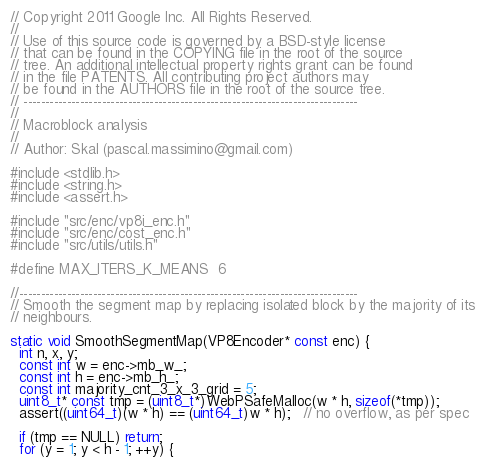Convert code to text. <code><loc_0><loc_0><loc_500><loc_500><_C_>// Copyright 2011 Google Inc. All Rights Reserved.
//
// Use of this source code is governed by a BSD-style license
// that can be found in the COPYING file in the root of the source
// tree. An additional intellectual property rights grant can be found
// in the file PATENTS. All contributing project authors may
// be found in the AUTHORS file in the root of the source tree.
// -----------------------------------------------------------------------------
//
// Macroblock analysis
//
// Author: Skal (pascal.massimino@gmail.com)

#include <stdlib.h>
#include <string.h>
#include <assert.h>

#include "src/enc/vp8i_enc.h"
#include "src/enc/cost_enc.h"
#include "src/utils/utils.h"

#define MAX_ITERS_K_MEANS  6

//------------------------------------------------------------------------------
// Smooth the segment map by replacing isolated block by the majority of its
// neighbours.

static void SmoothSegmentMap(VP8Encoder* const enc) {
  int n, x, y;
  const int w = enc->mb_w_;
  const int h = enc->mb_h_;
  const int majority_cnt_3_x_3_grid = 5;
  uint8_t* const tmp = (uint8_t*)WebPSafeMalloc(w * h, sizeof(*tmp));
  assert((uint64_t)(w * h) == (uint64_t)w * h);   // no overflow, as per spec

  if (tmp == NULL) return;
  for (y = 1; y < h - 1; ++y) {</code> 